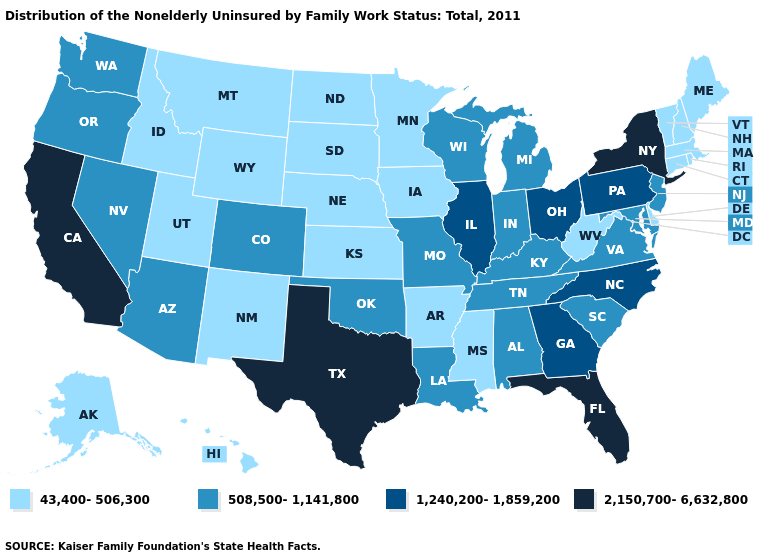What is the value of Massachusetts?
Keep it brief. 43,400-506,300. Among the states that border Utah , does Idaho have the lowest value?
Concise answer only. Yes. Does Rhode Island have the lowest value in the Northeast?
Answer briefly. Yes. Does Texas have the highest value in the South?
Keep it brief. Yes. What is the highest value in states that border South Dakota?
Quick response, please. 43,400-506,300. Among the states that border Pennsylvania , which have the highest value?
Quick response, please. New York. What is the value of Wisconsin?
Be succinct. 508,500-1,141,800. What is the lowest value in the USA?
Answer briefly. 43,400-506,300. What is the highest value in the South ?
Short answer required. 2,150,700-6,632,800. Name the states that have a value in the range 508,500-1,141,800?
Quick response, please. Alabama, Arizona, Colorado, Indiana, Kentucky, Louisiana, Maryland, Michigan, Missouri, Nevada, New Jersey, Oklahoma, Oregon, South Carolina, Tennessee, Virginia, Washington, Wisconsin. What is the highest value in the USA?
Keep it brief. 2,150,700-6,632,800. What is the value of Massachusetts?
Quick response, please. 43,400-506,300. How many symbols are there in the legend?
Give a very brief answer. 4. Name the states that have a value in the range 43,400-506,300?
Short answer required. Alaska, Arkansas, Connecticut, Delaware, Hawaii, Idaho, Iowa, Kansas, Maine, Massachusetts, Minnesota, Mississippi, Montana, Nebraska, New Hampshire, New Mexico, North Dakota, Rhode Island, South Dakota, Utah, Vermont, West Virginia, Wyoming. Name the states that have a value in the range 1,240,200-1,859,200?
Answer briefly. Georgia, Illinois, North Carolina, Ohio, Pennsylvania. 